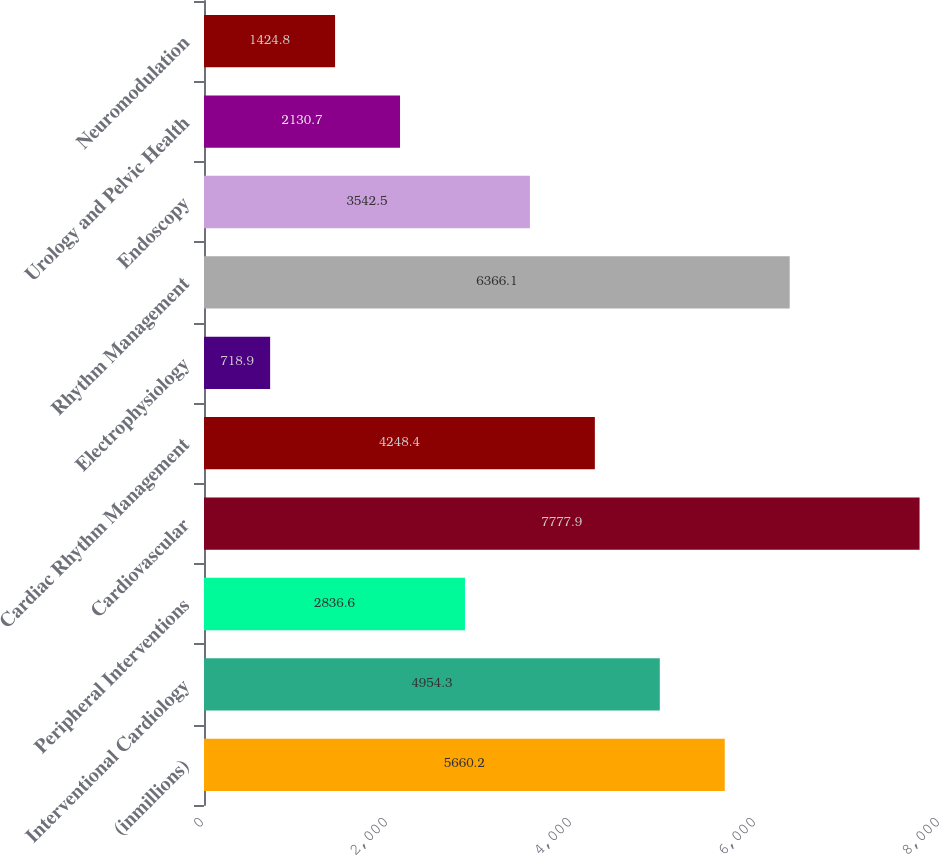<chart> <loc_0><loc_0><loc_500><loc_500><bar_chart><fcel>(inmillions)<fcel>Interventional Cardiology<fcel>Peripheral Interventions<fcel>Cardiovascular<fcel>Cardiac Rhythm Management<fcel>Electrophysiology<fcel>Rhythm Management<fcel>Endoscopy<fcel>Urology and Pelvic Health<fcel>Neuromodulation<nl><fcel>5660.2<fcel>4954.3<fcel>2836.6<fcel>7777.9<fcel>4248.4<fcel>718.9<fcel>6366.1<fcel>3542.5<fcel>2130.7<fcel>1424.8<nl></chart> 